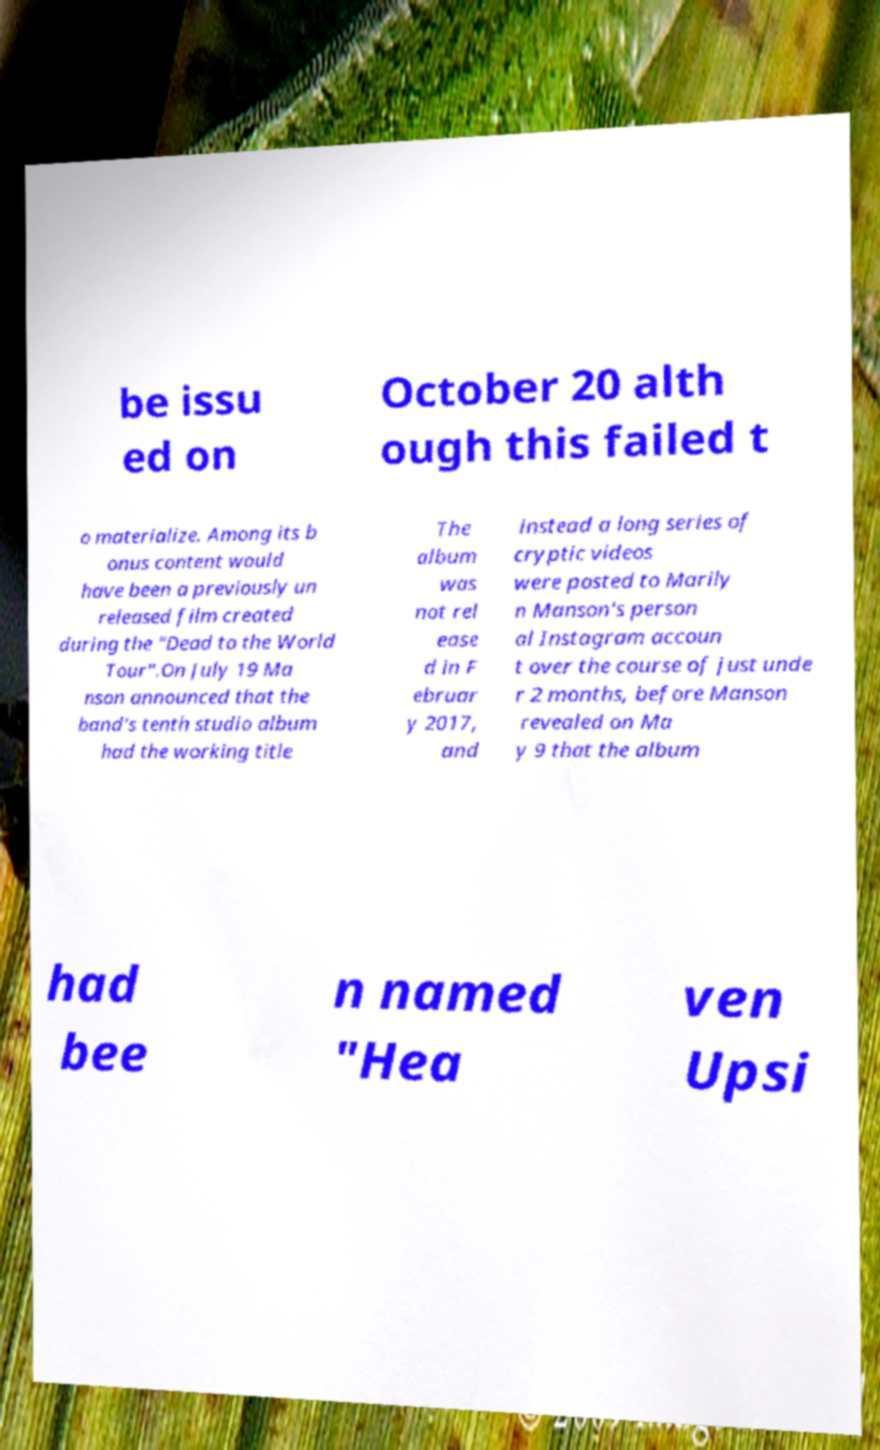Could you extract and type out the text from this image? be issu ed on October 20 alth ough this failed t o materialize. Among its b onus content would have been a previously un released film created during the "Dead to the World Tour".On July 19 Ma nson announced that the band's tenth studio album had the working title The album was not rel ease d in F ebruar y 2017, and instead a long series of cryptic videos were posted to Marily n Manson's person al Instagram accoun t over the course of just unde r 2 months, before Manson revealed on Ma y 9 that the album had bee n named "Hea ven Upsi 